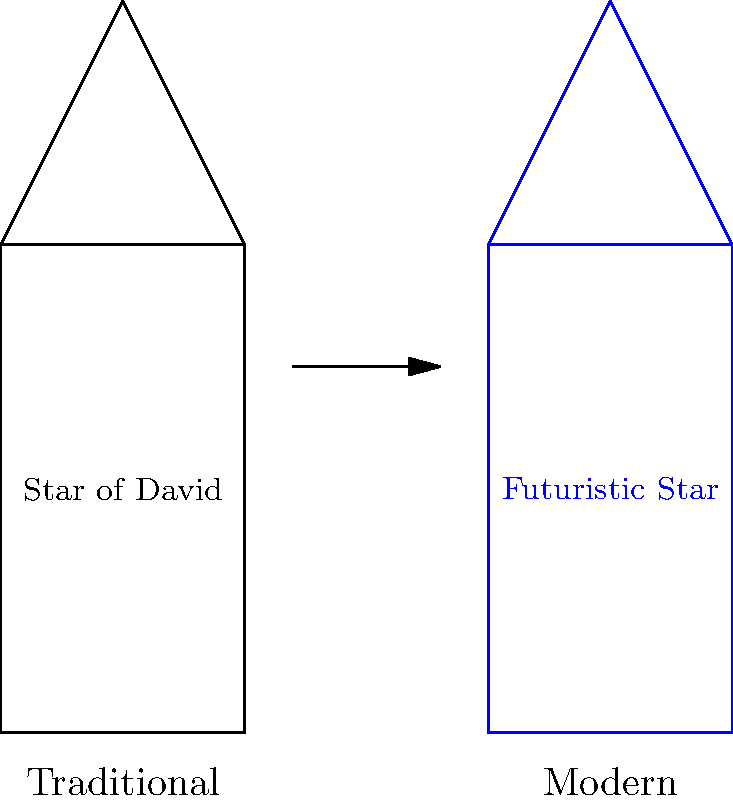In recent films like "A Serious Man" by the Coen Brothers, how has the traditional Star of David symbol been reimagined to reflect contemporary Jewish identity? 1. Traditional Star of David:
   - Typically depicted as a six-pointed star
   - Often shown in yellow or gold
   - Associated with Jewish heritage and religious identity

2. Modern interpretation in film:
   - The Coen Brothers' "A Serious Man" (2009) subtly alters this symbol
   - The star is depicted with sleeker, more angular lines
   - Often shown in cooler colors like blue or silver

3. Symbolic meaning of the change:
   - Represents the evolving nature of Jewish identity in the modern world
   - Reflects the tension between tradition and modernity
   - Hints at the protagonist's struggle with faith and cultural identity

4. Cinematic context:
   - The reimagined star appears in dream sequences and symbolic moments
   - It serves as a visual metaphor for the main character's spiritual journey
   - The altered symbol bridges the gap between ancient tradition and contemporary life

5. Impact on Jewish millennial viewers:
   - Encourages reflection on personal relationship with faith and culture
   - Resonates with the experience of balancing tradition and modern life
   - Sparks discussions about the evolution of Jewish symbolism in media
Answer: Sleeker, more angular design in cooler colors, symbolizing evolving Jewish identity 